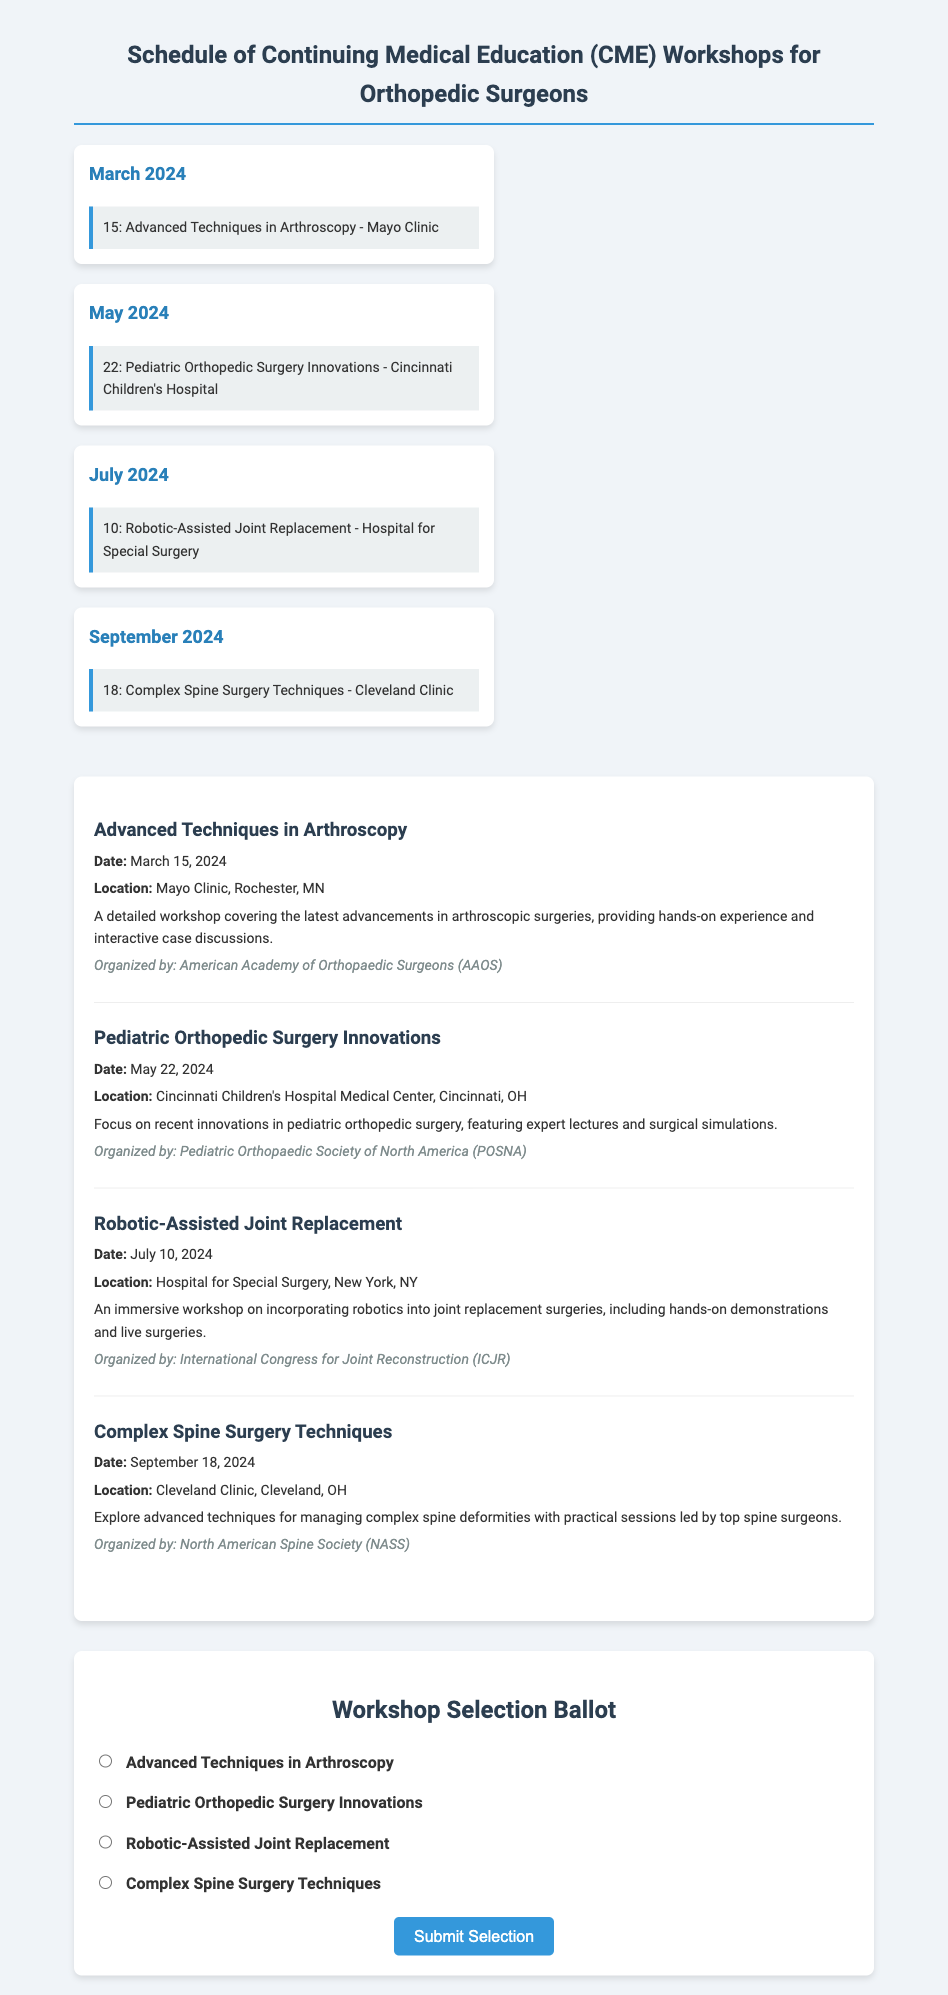What is the date of the Advanced Techniques in Arthroscopy workshop? The date is specifically mentioned in the workshop details section.
Answer: March 15, 2024 Where will the Pediatric Orthopedic Surgery Innovations workshop take place? The location is provided in the workshop details.
Answer: Cincinnati Children's Hospital Medical Center, Cincinnati, OH What is the organizer of the Robotic-Assisted Joint Replacement workshop? The organizer is indicated in the workshop details.
Answer: International Congress for Joint Reconstruction (ICJR) Which workshop is scheduled for September? The schedule lists events in each month, identifying the one in September.
Answer: Complex Spine Surgery Techniques How many workshops are listed in the document? The document counts the workshops mentioned in the workshop section.
Answer: Four What type of content does the ballot section contain? The ballot section is specifically designed to allow participants to select their preferred workshop.
Answer: Workshop selection options What is the theme of the workshop on May 22, 2024? The theme is part of the workshop details, focusing on innovations in the specified field.
Answer: Innovations in pediatric orthopedic surgery Which two workshops are held in the summer months? The summer months are typically June, July, and August, so referencing the calendar reveals the two relevant workshops.
Answer: Robotic-Assisted Joint Replacement and Complex Spine Surgery Techniques 